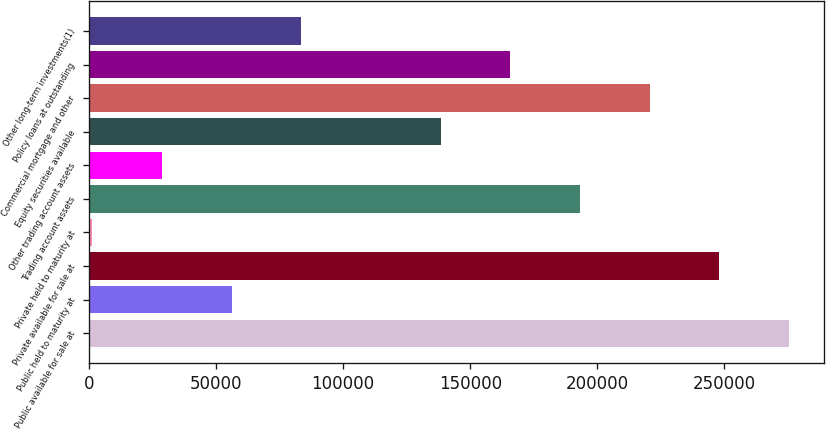Convert chart. <chart><loc_0><loc_0><loc_500><loc_500><bar_chart><fcel>Public available for sale at<fcel>Public held to maturity at<fcel>Private available for sale at<fcel>Private held to maturity at<fcel>Trading account assets<fcel>Other trading account assets<fcel>Equity securities available<fcel>Commercial mortgage and other<fcel>Policy loans at outstanding<fcel>Other long-term investments(1)<nl><fcel>275470<fcel>56122.8<fcel>248052<fcel>1286<fcel>193215<fcel>28704.4<fcel>138378<fcel>220633<fcel>165796<fcel>83541.2<nl></chart> 